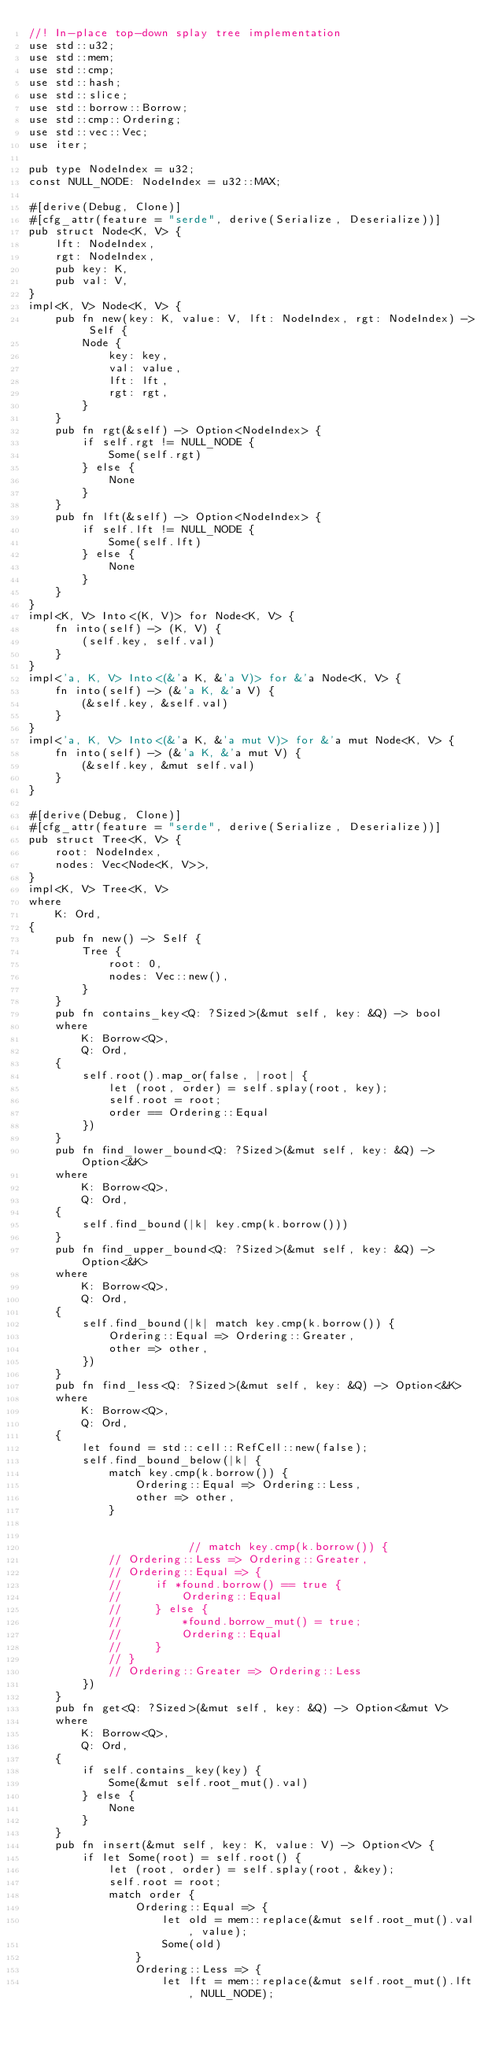<code> <loc_0><loc_0><loc_500><loc_500><_Rust_>//! In-place top-down splay tree implementation
use std::u32;
use std::mem;
use std::cmp;
use std::hash;
use std::slice;
use std::borrow::Borrow;
use std::cmp::Ordering;
use std::vec::Vec;
use iter;

pub type NodeIndex = u32;
const NULL_NODE: NodeIndex = u32::MAX;

#[derive(Debug, Clone)]
#[cfg_attr(feature = "serde", derive(Serialize, Deserialize))]
pub struct Node<K, V> {
    lft: NodeIndex,
    rgt: NodeIndex,
    pub key: K,
    pub val: V,
}
impl<K, V> Node<K, V> {
    pub fn new(key: K, value: V, lft: NodeIndex, rgt: NodeIndex) -> Self {
        Node {
            key: key,
            val: value,
            lft: lft,
            rgt: rgt,
        }
    }
    pub fn rgt(&self) -> Option<NodeIndex> {
        if self.rgt != NULL_NODE {
            Some(self.rgt)
        } else {
            None
        }
    }
    pub fn lft(&self) -> Option<NodeIndex> {
        if self.lft != NULL_NODE {
            Some(self.lft)
        } else {
            None
        }
    }
}
impl<K, V> Into<(K, V)> for Node<K, V> {
    fn into(self) -> (K, V) {
        (self.key, self.val)
    }
}
impl<'a, K, V> Into<(&'a K, &'a V)> for &'a Node<K, V> {
    fn into(self) -> (&'a K, &'a V) {
        (&self.key, &self.val)
    }
}
impl<'a, K, V> Into<(&'a K, &'a mut V)> for &'a mut Node<K, V> {
    fn into(self) -> (&'a K, &'a mut V) {
        (&self.key, &mut self.val)
    }
}

#[derive(Debug, Clone)]
#[cfg_attr(feature = "serde", derive(Serialize, Deserialize))]
pub struct Tree<K, V> {
    root: NodeIndex,
    nodes: Vec<Node<K, V>>,
}
impl<K, V> Tree<K, V>
where
    K: Ord,
{
    pub fn new() -> Self {
        Tree {
            root: 0,
            nodes: Vec::new(),
        }
    }
    pub fn contains_key<Q: ?Sized>(&mut self, key: &Q) -> bool
    where
        K: Borrow<Q>,
        Q: Ord,
    {
        self.root().map_or(false, |root| {
            let (root, order) = self.splay(root, key);
            self.root = root;
            order == Ordering::Equal
        })
    }
    pub fn find_lower_bound<Q: ?Sized>(&mut self, key: &Q) -> Option<&K>
    where
        K: Borrow<Q>,
        Q: Ord,
    {
        self.find_bound(|k| key.cmp(k.borrow()))
    }
    pub fn find_upper_bound<Q: ?Sized>(&mut self, key: &Q) -> Option<&K>
    where
        K: Borrow<Q>,
        Q: Ord,
    {
        self.find_bound(|k| match key.cmp(k.borrow()) {
            Ordering::Equal => Ordering::Greater,
            other => other,
        })
    }
    pub fn find_less<Q: ?Sized>(&mut self, key: &Q) -> Option<&K>
    where
        K: Borrow<Q>,
        Q: Ord,
    {
        let found = std::cell::RefCell::new(false);
        self.find_bound_below(|k| {
            match key.cmp(k.borrow()) {
                Ordering::Equal => Ordering::Less,
                other => other,
            }


                        // match key.cmp(k.borrow()) {
            // Ordering::Less => Ordering::Greater,
            // Ordering::Equal => {
            //     if *found.borrow() == true {
            //         Ordering::Equal
            //     } else {
            //         *found.borrow_mut() = true;
            //         Ordering::Equal
            //     }
            // }
            // Ordering::Greater => Ordering::Less
        })
    }
    pub fn get<Q: ?Sized>(&mut self, key: &Q) -> Option<&mut V>
    where
        K: Borrow<Q>,
        Q: Ord,
    {
        if self.contains_key(key) {
            Some(&mut self.root_mut().val)
        } else {
            None
        }
    }
    pub fn insert(&mut self, key: K, value: V) -> Option<V> {
        if let Some(root) = self.root() {
            let (root, order) = self.splay(root, &key);
            self.root = root;
            match order {
                Ordering::Equal => {
                    let old = mem::replace(&mut self.root_mut().val, value);
                    Some(old)
                }
                Ordering::Less => {
                    let lft = mem::replace(&mut self.root_mut().lft, NULL_NODE);</code> 